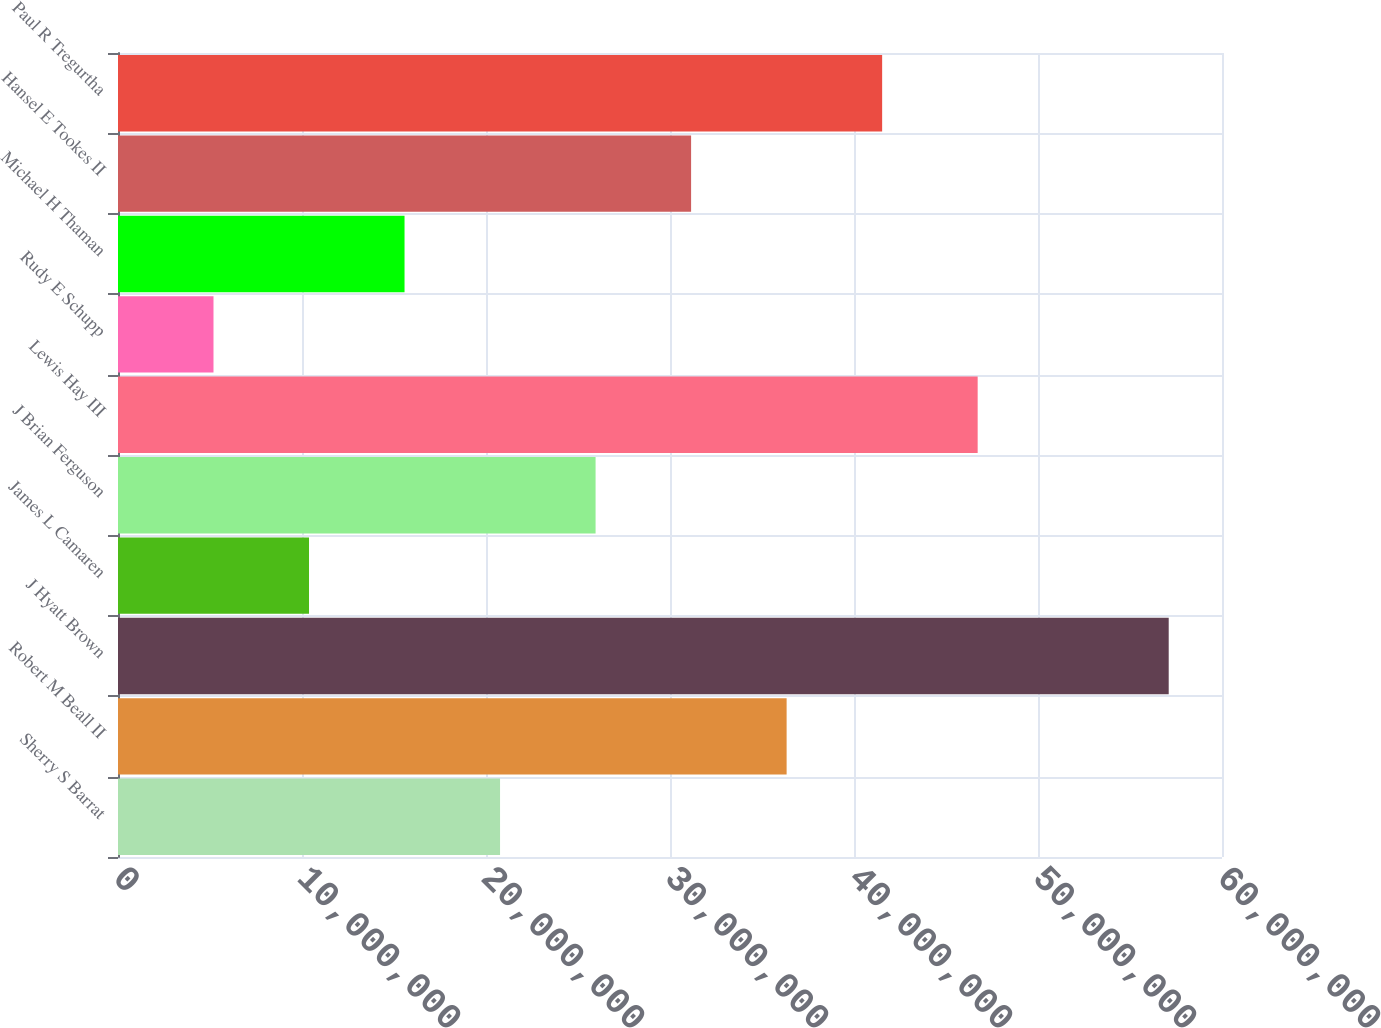Convert chart. <chart><loc_0><loc_0><loc_500><loc_500><bar_chart><fcel>Sherry S Barrat<fcel>Robert M Beall II<fcel>J Hyatt Brown<fcel>James L Camaren<fcel>J Brian Ferguson<fcel>Lewis Hay III<fcel>Rudy E Schupp<fcel>Michael H Thaman<fcel>Hansel E Tookes II<fcel>Paul R Tregurtha<nl><fcel>2.0764e+07<fcel>3.63382e+07<fcel>5.71037e+07<fcel>1.03813e+07<fcel>2.59554e+07<fcel>4.67209e+07<fcel>5.18987e+06<fcel>1.55726e+07<fcel>3.11468e+07<fcel>4.15296e+07<nl></chart> 